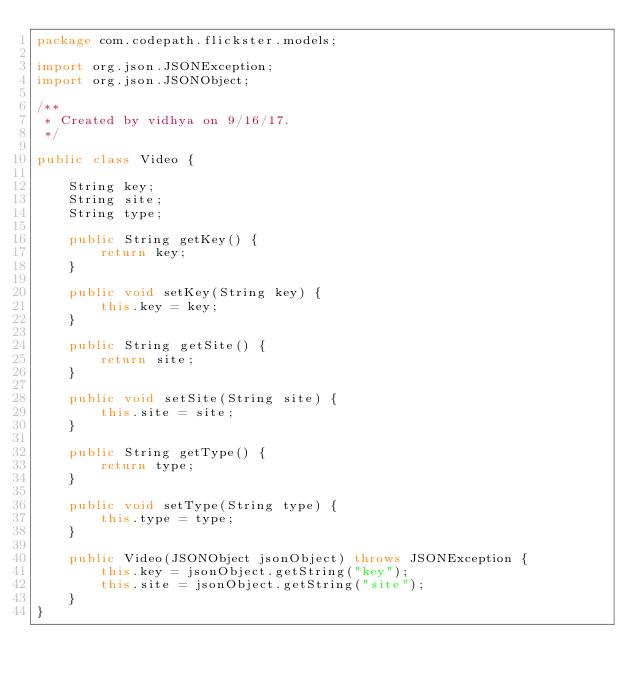<code> <loc_0><loc_0><loc_500><loc_500><_Java_>package com.codepath.flickster.models;

import org.json.JSONException;
import org.json.JSONObject;

/**
 * Created by vidhya on 9/16/17.
 */

public class Video {

    String key;
    String site;
    String type;

    public String getKey() {
        return key;
    }

    public void setKey(String key) {
        this.key = key;
    }

    public String getSite() {
        return site;
    }

    public void setSite(String site) {
        this.site = site;
    }

    public String getType() {
        return type;
    }

    public void setType(String type) {
        this.type = type;
    }

    public Video(JSONObject jsonObject) throws JSONException {
        this.key = jsonObject.getString("key");
        this.site = jsonObject.getString("site");
    }
}
</code> 